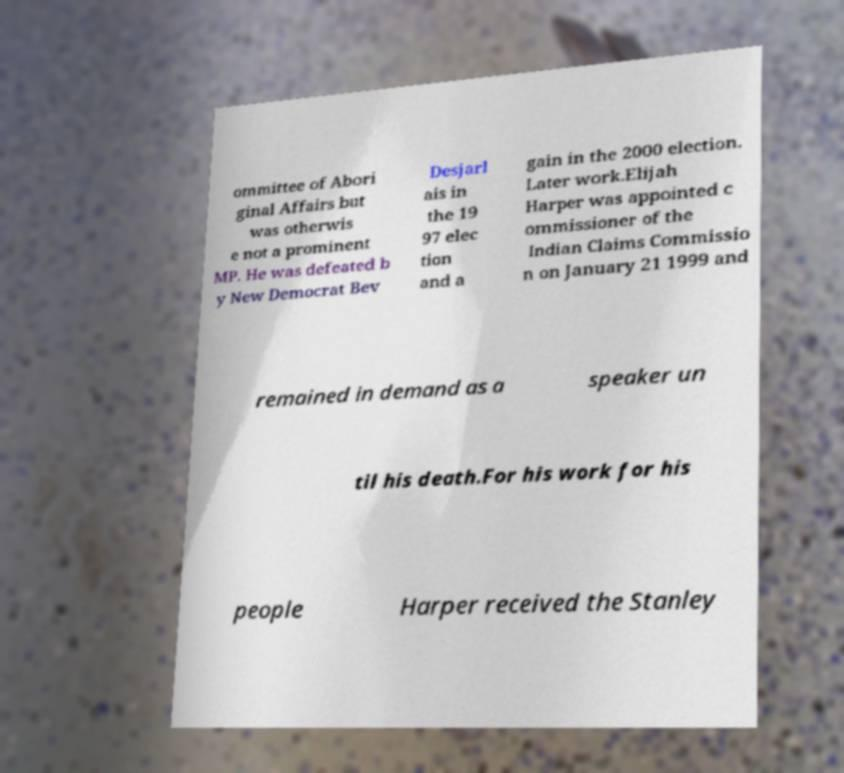Please read and relay the text visible in this image. What does it say? ommittee of Abori ginal Affairs but was otherwis e not a prominent MP. He was defeated b y New Democrat Bev Desjarl ais in the 19 97 elec tion and a gain in the 2000 election. Later work.Elijah Harper was appointed c ommissioner of the Indian Claims Commissio n on January 21 1999 and remained in demand as a speaker un til his death.For his work for his people Harper received the Stanley 